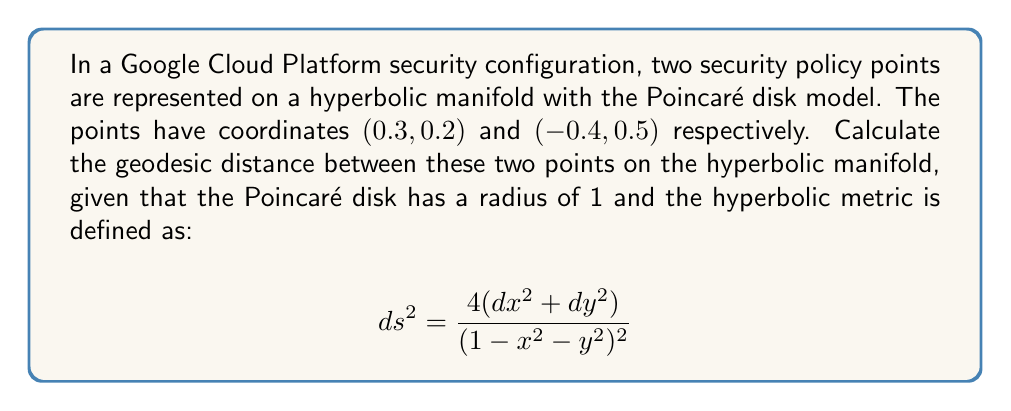Could you help me with this problem? To calculate the geodesic distance between two points on a hyperbolic manifold using the Poincaré disk model, we'll follow these steps:

1. Convert the given coordinates to complex numbers:
   $z_1 = 0.3 + 0.2i$
   $z_2 = -0.4 + 0.5i$

2. Use the formula for the hyperbolic distance in the Poincaré disk model:
   $$d(z_1, z_2) = 2 \tanh^{-1}\left|\frac{z_1 - z_2}{1 - \bar{z_1}z_2}\right|$$

3. Calculate $z_1 - z_2$:
   $z_1 - z_2 = (0.3 + 0.2i) - (-0.4 + 0.5i) = 0.7 - 0.3i$

4. Calculate $1 - \bar{z_1}z_2$:
   $\bar{z_1} = 0.3 - 0.2i$
   $\bar{z_1}z_2 = (0.3 - 0.2i)(-0.4 + 0.5i) = -0.12 - 0.15i + 0.08i - 0.1i = -0.12 - 0.17i$
   $1 - \bar{z_1}z_2 = 1.12 + 0.17i$

5. Calculate the fraction inside the absolute value:
   $$\frac{z_1 - z_2}{1 - \bar{z_1}z_2} = \frac{0.7 - 0.3i}{1.12 + 0.17i}$$

6. Multiply by the complex conjugate of the denominator to rationalize:
   $$\frac{(0.7 - 0.3i)(1.12 - 0.17i)}{(1.12 + 0.17i)(1.12 - 0.17i)} = \frac{0.835 - 0.287i}{1.2853} \approx 0.6497 - 0.2233i$$

7. Calculate the absolute value:
   $|0.6497 - 0.2233i| = \sqrt{0.6497^2 + 0.2233^2} \approx 0.6870$

8. Apply the $2 \tanh^{-1}$ function:
   $d(z_1, z_2) = 2 \tanh^{-1}(0.6870) \approx 1.7298$

Therefore, the geodesic distance between the two security policy points on the hyperbolic manifold is approximately 1.7298.
Answer: $1.7298$ 